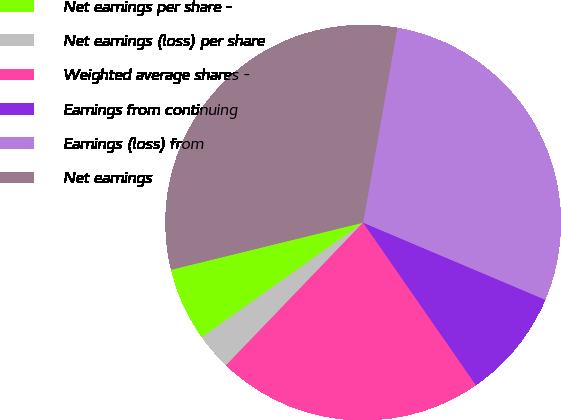Convert chart to OTSL. <chart><loc_0><loc_0><loc_500><loc_500><pie_chart><fcel>Net earnings per share -<fcel>Net earnings (loss) per share<fcel>Weighted average shares -<fcel>Earnings from continuing<fcel>Earnings (loss) from<fcel>Net earnings<nl><fcel>5.99%<fcel>3.0%<fcel>21.84%<fcel>8.97%<fcel>28.61%<fcel>31.6%<nl></chart> 